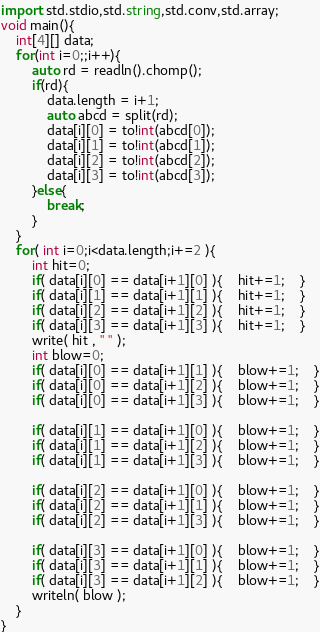<code> <loc_0><loc_0><loc_500><loc_500><_D_>import std.stdio,std.string,std.conv,std.array;
void main(){
	int[4][] data;
	for(int i=0;;i++){
		auto rd = readln().chomp();
		if(rd){
			data.length = i+1;
			auto abcd = split(rd);
			data[i][0] = to!int(abcd[0]);
			data[i][1] = to!int(abcd[1]);
			data[i][2] = to!int(abcd[2]);
			data[i][3] = to!int(abcd[3]);
		}else{
			break;
		}
	}
	for( int i=0;i<data.length;i+=2 ){
		int hit=0;
		if( data[i][0] == data[i+1][0] ){	hit+=1;	}
		if( data[i][1] == data[i+1][1] ){	hit+=1;	}
		if( data[i][2] == data[i+1][2] ){	hit+=1;	}
		if( data[i][3] == data[i+1][3] ){	hit+=1;	}
		write( hit , " " );
		int blow=0;
		if( data[i][0] == data[i+1][1] ){	blow+=1;	}
		if( data[i][0] == data[i+1][2] ){	blow+=1;	}
		if( data[i][0] == data[i+1][3] ){	blow+=1;	}
		
		if( data[i][1] == data[i+1][0] ){	blow+=1;	}
		if( data[i][1] == data[i+1][2] ){	blow+=1;	}
		if( data[i][1] == data[i+1][3] ){	blow+=1;	}

		if( data[i][2] == data[i+1][0] ){	blow+=1;	}
		if( data[i][2] == data[i+1][1] ){	blow+=1;	}
		if( data[i][2] == data[i+1][3] ){	blow+=1;	}
		
		if( data[i][3] == data[i+1][0] ){	blow+=1;	}
		if( data[i][3] == data[i+1][1] ){	blow+=1;	}
		if( data[i][3] == data[i+1][2] ){	blow+=1;	}
		writeln( blow );
	}
}</code> 